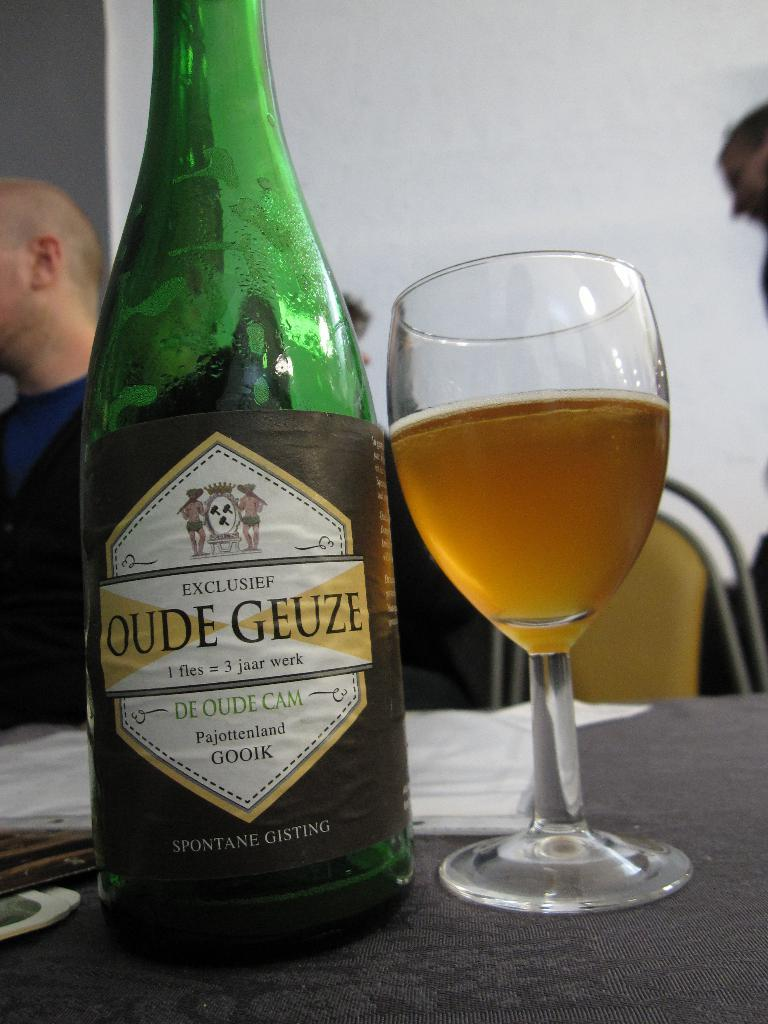<image>
Write a terse but informative summary of the picture. An open container or Oude Geuze next to a half full glass. 